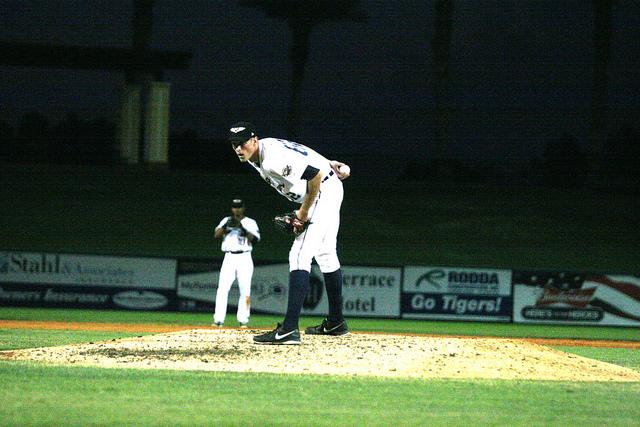How high does the pitcher have his socks pulled up?
Concise answer only. Knee. Which hand does the pitcher throw with?
Short answer required. Right. What sport are they playing?
Short answer required. Baseball. What sport is being played?
Write a very short answer. Baseball. What is the pitcher looking at?
Answer briefly. Batter. 